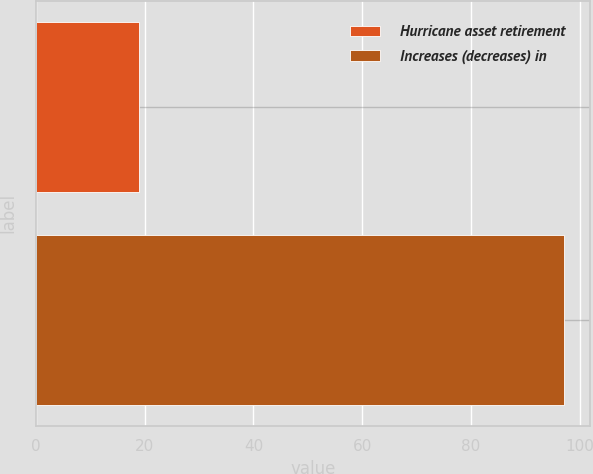Convert chart. <chart><loc_0><loc_0><loc_500><loc_500><bar_chart><fcel>Hurricane asset retirement<fcel>Increases (decreases) in<nl><fcel>19<fcel>97<nl></chart> 